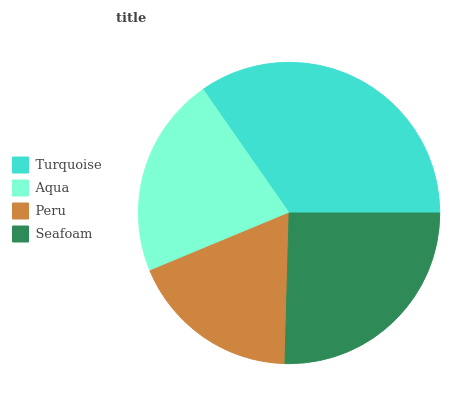Is Peru the minimum?
Answer yes or no. Yes. Is Turquoise the maximum?
Answer yes or no. Yes. Is Aqua the minimum?
Answer yes or no. No. Is Aqua the maximum?
Answer yes or no. No. Is Turquoise greater than Aqua?
Answer yes or no. Yes. Is Aqua less than Turquoise?
Answer yes or no. Yes. Is Aqua greater than Turquoise?
Answer yes or no. No. Is Turquoise less than Aqua?
Answer yes or no. No. Is Seafoam the high median?
Answer yes or no. Yes. Is Aqua the low median?
Answer yes or no. Yes. Is Aqua the high median?
Answer yes or no. No. Is Seafoam the low median?
Answer yes or no. No. 